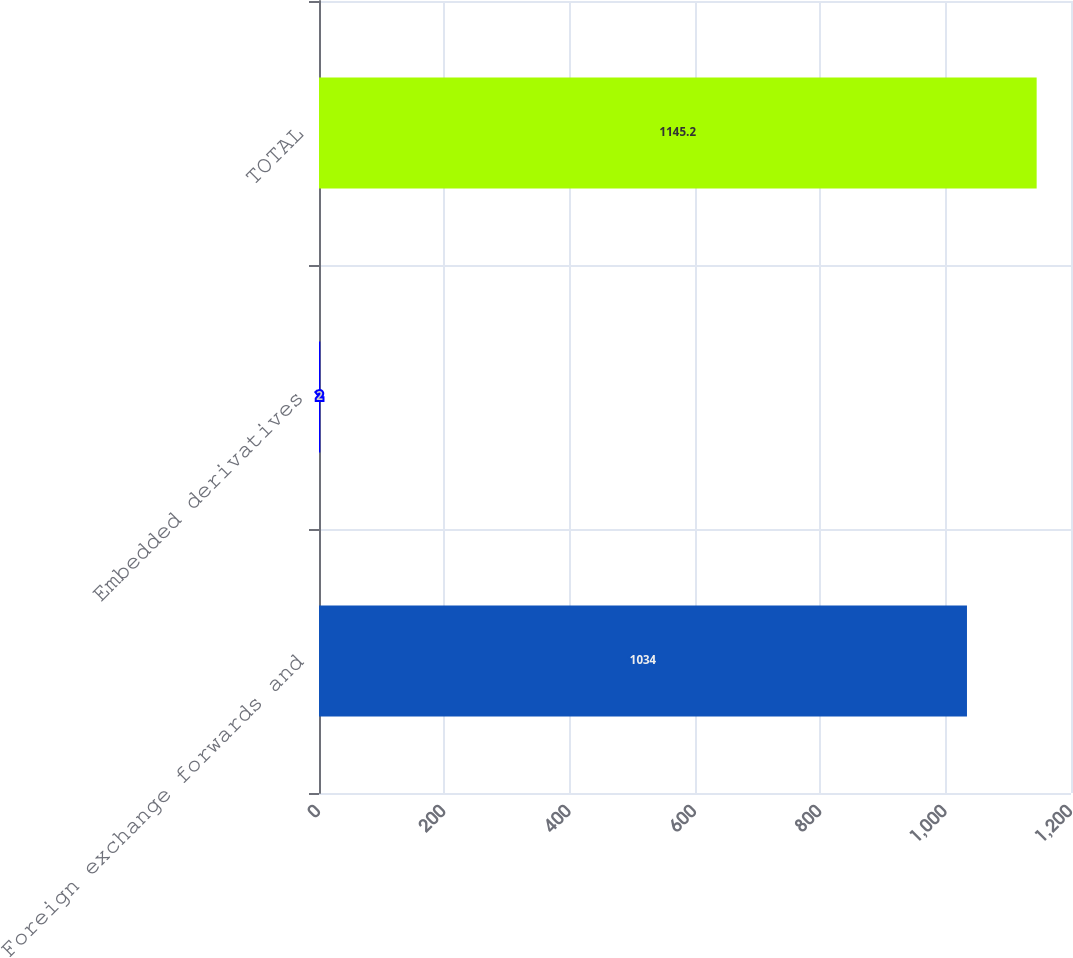Convert chart. <chart><loc_0><loc_0><loc_500><loc_500><bar_chart><fcel>Foreign exchange forwards and<fcel>Embedded derivatives<fcel>TOTAL<nl><fcel>1034<fcel>2<fcel>1145.2<nl></chart> 